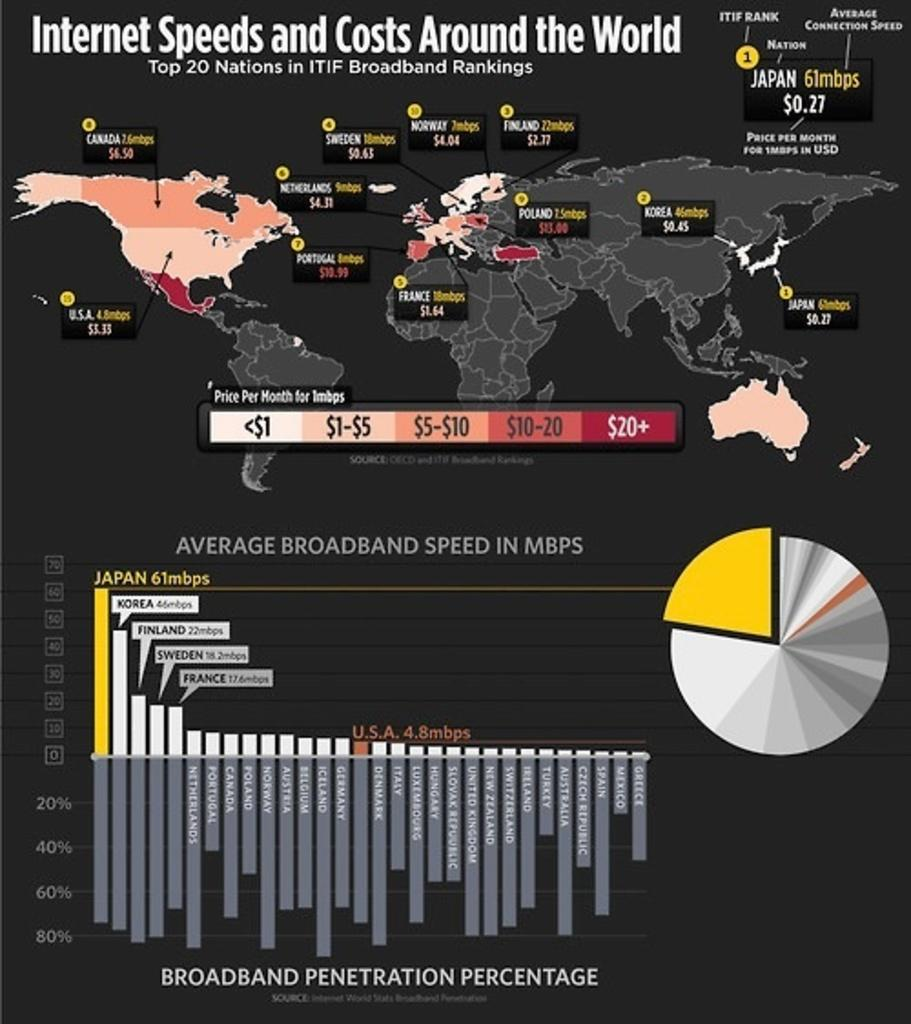<image>
Describe the image concisely. A poster shows the internet speeds and costs from around the world. 